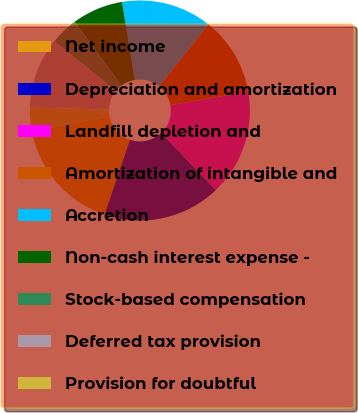Convert chart. <chart><loc_0><loc_0><loc_500><loc_500><pie_chart><fcel>Net income<fcel>Depreciation and amortization<fcel>Landfill depletion and<fcel>Amortization of intangible and<fcel>Accretion<fcel>Non-cash interest expense -<fcel>Stock-based compensation<fcel>Deferred tax provision<fcel>Provision for doubtful<nl><fcel>16.76%<fcel>17.34%<fcel>15.61%<fcel>11.56%<fcel>13.29%<fcel>7.51%<fcel>4.05%<fcel>10.4%<fcel>3.47%<nl></chart> 